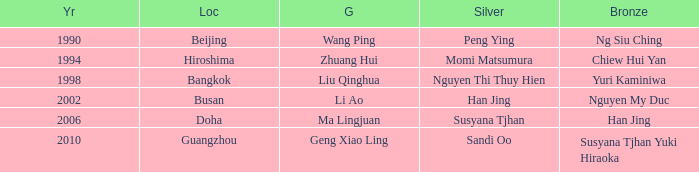Help me parse the entirety of this table. {'header': ['Yr', 'Loc', 'G', 'Silver', 'Bronze'], 'rows': [['1990', 'Beijing', 'Wang Ping', 'Peng Ying', 'Ng Siu Ching'], ['1994', 'Hiroshima', 'Zhuang Hui', 'Momi Matsumura', 'Chiew Hui Yan'], ['1998', 'Bangkok', 'Liu Qinghua', 'Nguyen Thi Thuy Hien', 'Yuri Kaminiwa'], ['2002', 'Busan', 'Li Ao', 'Han Jing', 'Nguyen My Duc'], ['2006', 'Doha', 'Ma Lingjuan', 'Susyana Tjhan', 'Han Jing'], ['2010', 'Guangzhou', 'Geng Xiao Ling', 'Sandi Oo', 'Susyana Tjhan Yuki Hiraoka']]} What's the Bronze with the Year of 1998? Yuri Kaminiwa. 